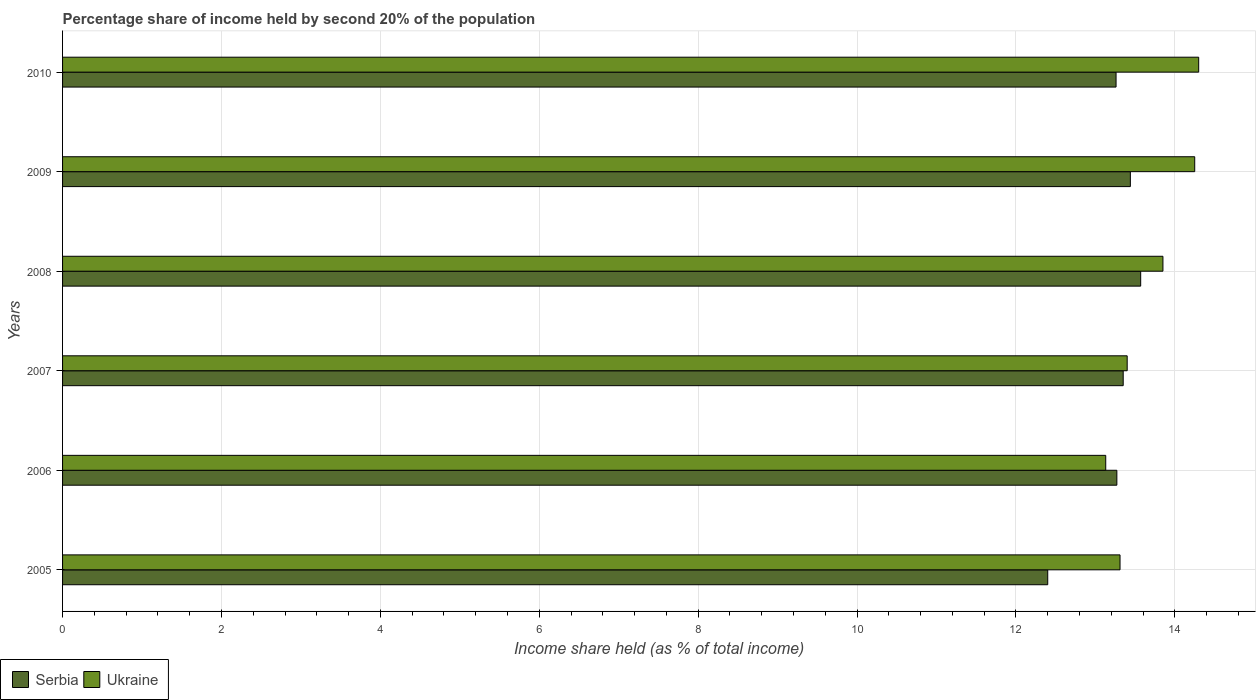How many different coloured bars are there?
Give a very brief answer. 2. How many groups of bars are there?
Give a very brief answer. 6. Are the number of bars on each tick of the Y-axis equal?
Make the answer very short. Yes. How many bars are there on the 5th tick from the top?
Offer a terse response. 2. How many bars are there on the 6th tick from the bottom?
Make the answer very short. 2. What is the share of income held by second 20% of the population in Serbia in 2006?
Offer a terse response. 13.27. Across all years, what is the maximum share of income held by second 20% of the population in Ukraine?
Your answer should be compact. 14.3. In which year was the share of income held by second 20% of the population in Ukraine minimum?
Give a very brief answer. 2006. What is the total share of income held by second 20% of the population in Serbia in the graph?
Your answer should be compact. 79.29. What is the difference between the share of income held by second 20% of the population in Ukraine in 2006 and that in 2009?
Ensure brevity in your answer.  -1.12. What is the difference between the share of income held by second 20% of the population in Serbia in 2006 and the share of income held by second 20% of the population in Ukraine in 2009?
Provide a succinct answer. -0.98. What is the average share of income held by second 20% of the population in Ukraine per year?
Your response must be concise. 13.71. In the year 2007, what is the difference between the share of income held by second 20% of the population in Serbia and share of income held by second 20% of the population in Ukraine?
Offer a terse response. -0.05. What is the ratio of the share of income held by second 20% of the population in Ukraine in 2005 to that in 2008?
Provide a short and direct response. 0.96. Is the difference between the share of income held by second 20% of the population in Serbia in 2007 and 2010 greater than the difference between the share of income held by second 20% of the population in Ukraine in 2007 and 2010?
Provide a short and direct response. Yes. What is the difference between the highest and the second highest share of income held by second 20% of the population in Serbia?
Give a very brief answer. 0.13. What is the difference between the highest and the lowest share of income held by second 20% of the population in Ukraine?
Your response must be concise. 1.17. What does the 1st bar from the top in 2005 represents?
Your answer should be very brief. Ukraine. What does the 2nd bar from the bottom in 2005 represents?
Provide a short and direct response. Ukraine. Are the values on the major ticks of X-axis written in scientific E-notation?
Ensure brevity in your answer.  No. Does the graph contain grids?
Provide a short and direct response. Yes. How many legend labels are there?
Ensure brevity in your answer.  2. How are the legend labels stacked?
Provide a succinct answer. Horizontal. What is the title of the graph?
Provide a short and direct response. Percentage share of income held by second 20% of the population. Does "Guinea-Bissau" appear as one of the legend labels in the graph?
Offer a very short reply. No. What is the label or title of the X-axis?
Provide a short and direct response. Income share held (as % of total income). What is the Income share held (as % of total income) in Serbia in 2005?
Your answer should be very brief. 12.4. What is the Income share held (as % of total income) in Ukraine in 2005?
Provide a succinct answer. 13.31. What is the Income share held (as % of total income) in Serbia in 2006?
Offer a terse response. 13.27. What is the Income share held (as % of total income) in Ukraine in 2006?
Provide a short and direct response. 13.13. What is the Income share held (as % of total income) of Serbia in 2007?
Keep it short and to the point. 13.35. What is the Income share held (as % of total income) in Ukraine in 2007?
Give a very brief answer. 13.4. What is the Income share held (as % of total income) of Serbia in 2008?
Offer a very short reply. 13.57. What is the Income share held (as % of total income) in Ukraine in 2008?
Make the answer very short. 13.85. What is the Income share held (as % of total income) in Serbia in 2009?
Provide a short and direct response. 13.44. What is the Income share held (as % of total income) in Ukraine in 2009?
Provide a succinct answer. 14.25. What is the Income share held (as % of total income) in Serbia in 2010?
Make the answer very short. 13.26. What is the Income share held (as % of total income) in Ukraine in 2010?
Ensure brevity in your answer.  14.3. Across all years, what is the maximum Income share held (as % of total income) in Serbia?
Make the answer very short. 13.57. Across all years, what is the minimum Income share held (as % of total income) in Serbia?
Your answer should be compact. 12.4. Across all years, what is the minimum Income share held (as % of total income) in Ukraine?
Make the answer very short. 13.13. What is the total Income share held (as % of total income) in Serbia in the graph?
Offer a very short reply. 79.29. What is the total Income share held (as % of total income) in Ukraine in the graph?
Your answer should be compact. 82.24. What is the difference between the Income share held (as % of total income) of Serbia in 2005 and that in 2006?
Keep it short and to the point. -0.87. What is the difference between the Income share held (as % of total income) in Ukraine in 2005 and that in 2006?
Your answer should be very brief. 0.18. What is the difference between the Income share held (as % of total income) of Serbia in 2005 and that in 2007?
Your answer should be compact. -0.95. What is the difference between the Income share held (as % of total income) of Ukraine in 2005 and that in 2007?
Keep it short and to the point. -0.09. What is the difference between the Income share held (as % of total income) of Serbia in 2005 and that in 2008?
Your answer should be compact. -1.17. What is the difference between the Income share held (as % of total income) of Ukraine in 2005 and that in 2008?
Give a very brief answer. -0.54. What is the difference between the Income share held (as % of total income) of Serbia in 2005 and that in 2009?
Provide a succinct answer. -1.04. What is the difference between the Income share held (as % of total income) in Ukraine in 2005 and that in 2009?
Provide a short and direct response. -0.94. What is the difference between the Income share held (as % of total income) of Serbia in 2005 and that in 2010?
Provide a short and direct response. -0.86. What is the difference between the Income share held (as % of total income) in Ukraine in 2005 and that in 2010?
Your response must be concise. -0.99. What is the difference between the Income share held (as % of total income) of Serbia in 2006 and that in 2007?
Keep it short and to the point. -0.08. What is the difference between the Income share held (as % of total income) of Ukraine in 2006 and that in 2007?
Ensure brevity in your answer.  -0.27. What is the difference between the Income share held (as % of total income) in Serbia in 2006 and that in 2008?
Offer a terse response. -0.3. What is the difference between the Income share held (as % of total income) of Ukraine in 2006 and that in 2008?
Offer a terse response. -0.72. What is the difference between the Income share held (as % of total income) in Serbia in 2006 and that in 2009?
Keep it short and to the point. -0.17. What is the difference between the Income share held (as % of total income) in Ukraine in 2006 and that in 2009?
Provide a succinct answer. -1.12. What is the difference between the Income share held (as % of total income) of Serbia in 2006 and that in 2010?
Give a very brief answer. 0.01. What is the difference between the Income share held (as % of total income) in Ukraine in 2006 and that in 2010?
Give a very brief answer. -1.17. What is the difference between the Income share held (as % of total income) in Serbia in 2007 and that in 2008?
Provide a succinct answer. -0.22. What is the difference between the Income share held (as % of total income) of Ukraine in 2007 and that in 2008?
Your answer should be very brief. -0.45. What is the difference between the Income share held (as % of total income) of Serbia in 2007 and that in 2009?
Your answer should be very brief. -0.09. What is the difference between the Income share held (as % of total income) in Ukraine in 2007 and that in 2009?
Provide a succinct answer. -0.85. What is the difference between the Income share held (as % of total income) of Serbia in 2007 and that in 2010?
Your answer should be very brief. 0.09. What is the difference between the Income share held (as % of total income) in Ukraine in 2007 and that in 2010?
Keep it short and to the point. -0.9. What is the difference between the Income share held (as % of total income) in Serbia in 2008 and that in 2009?
Your answer should be compact. 0.13. What is the difference between the Income share held (as % of total income) in Ukraine in 2008 and that in 2009?
Provide a succinct answer. -0.4. What is the difference between the Income share held (as % of total income) in Serbia in 2008 and that in 2010?
Your answer should be very brief. 0.31. What is the difference between the Income share held (as % of total income) in Ukraine in 2008 and that in 2010?
Keep it short and to the point. -0.45. What is the difference between the Income share held (as % of total income) in Serbia in 2009 and that in 2010?
Your answer should be compact. 0.18. What is the difference between the Income share held (as % of total income) in Serbia in 2005 and the Income share held (as % of total income) in Ukraine in 2006?
Provide a succinct answer. -0.73. What is the difference between the Income share held (as % of total income) of Serbia in 2005 and the Income share held (as % of total income) of Ukraine in 2008?
Your answer should be very brief. -1.45. What is the difference between the Income share held (as % of total income) of Serbia in 2005 and the Income share held (as % of total income) of Ukraine in 2009?
Make the answer very short. -1.85. What is the difference between the Income share held (as % of total income) of Serbia in 2005 and the Income share held (as % of total income) of Ukraine in 2010?
Your response must be concise. -1.9. What is the difference between the Income share held (as % of total income) of Serbia in 2006 and the Income share held (as % of total income) of Ukraine in 2007?
Offer a very short reply. -0.13. What is the difference between the Income share held (as % of total income) of Serbia in 2006 and the Income share held (as % of total income) of Ukraine in 2008?
Your answer should be compact. -0.58. What is the difference between the Income share held (as % of total income) of Serbia in 2006 and the Income share held (as % of total income) of Ukraine in 2009?
Keep it short and to the point. -0.98. What is the difference between the Income share held (as % of total income) of Serbia in 2006 and the Income share held (as % of total income) of Ukraine in 2010?
Provide a succinct answer. -1.03. What is the difference between the Income share held (as % of total income) of Serbia in 2007 and the Income share held (as % of total income) of Ukraine in 2009?
Offer a very short reply. -0.9. What is the difference between the Income share held (as % of total income) of Serbia in 2007 and the Income share held (as % of total income) of Ukraine in 2010?
Provide a succinct answer. -0.95. What is the difference between the Income share held (as % of total income) of Serbia in 2008 and the Income share held (as % of total income) of Ukraine in 2009?
Make the answer very short. -0.68. What is the difference between the Income share held (as % of total income) of Serbia in 2008 and the Income share held (as % of total income) of Ukraine in 2010?
Make the answer very short. -0.73. What is the difference between the Income share held (as % of total income) of Serbia in 2009 and the Income share held (as % of total income) of Ukraine in 2010?
Make the answer very short. -0.86. What is the average Income share held (as % of total income) in Serbia per year?
Provide a succinct answer. 13.21. What is the average Income share held (as % of total income) in Ukraine per year?
Make the answer very short. 13.71. In the year 2005, what is the difference between the Income share held (as % of total income) in Serbia and Income share held (as % of total income) in Ukraine?
Your answer should be compact. -0.91. In the year 2006, what is the difference between the Income share held (as % of total income) in Serbia and Income share held (as % of total income) in Ukraine?
Your answer should be compact. 0.14. In the year 2008, what is the difference between the Income share held (as % of total income) in Serbia and Income share held (as % of total income) in Ukraine?
Keep it short and to the point. -0.28. In the year 2009, what is the difference between the Income share held (as % of total income) in Serbia and Income share held (as % of total income) in Ukraine?
Give a very brief answer. -0.81. In the year 2010, what is the difference between the Income share held (as % of total income) of Serbia and Income share held (as % of total income) of Ukraine?
Give a very brief answer. -1.04. What is the ratio of the Income share held (as % of total income) of Serbia in 2005 to that in 2006?
Keep it short and to the point. 0.93. What is the ratio of the Income share held (as % of total income) of Ukraine in 2005 to that in 2006?
Provide a short and direct response. 1.01. What is the ratio of the Income share held (as % of total income) of Serbia in 2005 to that in 2007?
Give a very brief answer. 0.93. What is the ratio of the Income share held (as % of total income) of Ukraine in 2005 to that in 2007?
Your answer should be compact. 0.99. What is the ratio of the Income share held (as % of total income) in Serbia in 2005 to that in 2008?
Make the answer very short. 0.91. What is the ratio of the Income share held (as % of total income) in Ukraine in 2005 to that in 2008?
Offer a very short reply. 0.96. What is the ratio of the Income share held (as % of total income) in Serbia in 2005 to that in 2009?
Provide a short and direct response. 0.92. What is the ratio of the Income share held (as % of total income) in Ukraine in 2005 to that in 2009?
Your response must be concise. 0.93. What is the ratio of the Income share held (as % of total income) in Serbia in 2005 to that in 2010?
Your response must be concise. 0.94. What is the ratio of the Income share held (as % of total income) of Ukraine in 2005 to that in 2010?
Offer a very short reply. 0.93. What is the ratio of the Income share held (as % of total income) in Serbia in 2006 to that in 2007?
Offer a very short reply. 0.99. What is the ratio of the Income share held (as % of total income) in Ukraine in 2006 to that in 2007?
Ensure brevity in your answer.  0.98. What is the ratio of the Income share held (as % of total income) of Serbia in 2006 to that in 2008?
Your answer should be compact. 0.98. What is the ratio of the Income share held (as % of total income) of Ukraine in 2006 to that in 2008?
Offer a very short reply. 0.95. What is the ratio of the Income share held (as % of total income) in Serbia in 2006 to that in 2009?
Offer a very short reply. 0.99. What is the ratio of the Income share held (as % of total income) in Ukraine in 2006 to that in 2009?
Offer a terse response. 0.92. What is the ratio of the Income share held (as % of total income) in Ukraine in 2006 to that in 2010?
Keep it short and to the point. 0.92. What is the ratio of the Income share held (as % of total income) in Serbia in 2007 to that in 2008?
Provide a short and direct response. 0.98. What is the ratio of the Income share held (as % of total income) in Ukraine in 2007 to that in 2008?
Your answer should be compact. 0.97. What is the ratio of the Income share held (as % of total income) of Ukraine in 2007 to that in 2009?
Provide a succinct answer. 0.94. What is the ratio of the Income share held (as % of total income) of Serbia in 2007 to that in 2010?
Offer a very short reply. 1.01. What is the ratio of the Income share held (as % of total income) of Ukraine in 2007 to that in 2010?
Provide a succinct answer. 0.94. What is the ratio of the Income share held (as % of total income) in Serbia in 2008 to that in 2009?
Your answer should be very brief. 1.01. What is the ratio of the Income share held (as % of total income) of Ukraine in 2008 to that in 2009?
Ensure brevity in your answer.  0.97. What is the ratio of the Income share held (as % of total income) in Serbia in 2008 to that in 2010?
Make the answer very short. 1.02. What is the ratio of the Income share held (as % of total income) of Ukraine in 2008 to that in 2010?
Make the answer very short. 0.97. What is the ratio of the Income share held (as % of total income) in Serbia in 2009 to that in 2010?
Give a very brief answer. 1.01. What is the ratio of the Income share held (as % of total income) of Ukraine in 2009 to that in 2010?
Make the answer very short. 1. What is the difference between the highest and the second highest Income share held (as % of total income) of Serbia?
Offer a very short reply. 0.13. What is the difference between the highest and the lowest Income share held (as % of total income) in Serbia?
Keep it short and to the point. 1.17. What is the difference between the highest and the lowest Income share held (as % of total income) in Ukraine?
Your answer should be compact. 1.17. 